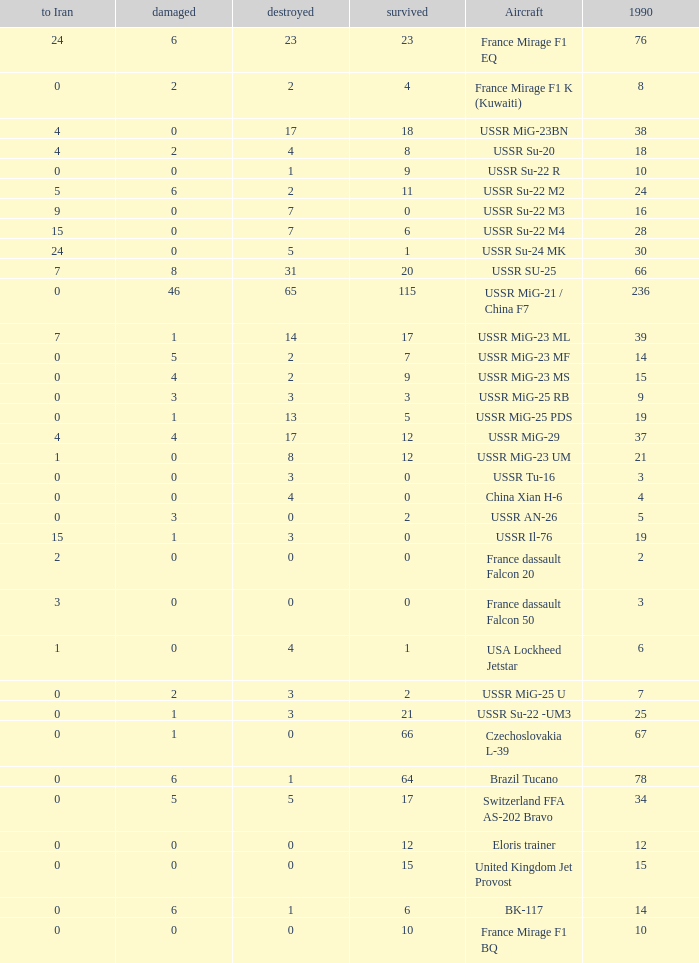If there were 14 in 1990 and 6 survived how many were destroyed? 1.0. 